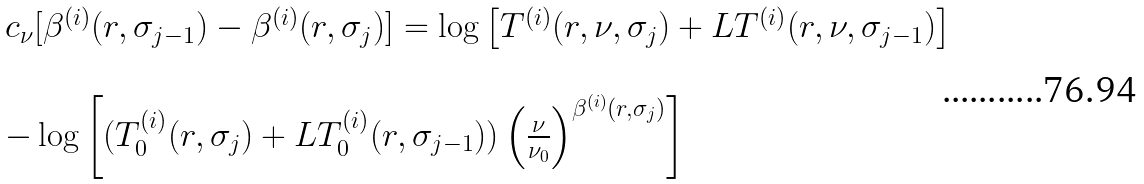<formula> <loc_0><loc_0><loc_500><loc_500>\begin{array} { l } c _ { \nu } [ \beta ^ { ( i ) } ( r , \sigma _ { j - 1 } ) - \beta ^ { ( i ) } ( r , \sigma _ { j } ) ] = \log \left [ T ^ { ( i ) } ( r , \nu , \sigma _ { j } ) + L T ^ { ( i ) } ( r , \nu , \sigma _ { j - 1 } ) \right ] \\ \\ - \log \left [ ( T ^ { ( i ) } _ { 0 } ( r , \sigma _ { j } ) + L T ^ { ( i ) } _ { 0 } ( r , \sigma _ { j - 1 } ) ) \left ( \frac { \nu } { \nu _ { 0 } } \right ) ^ { \beta ^ { ( i ) } ( r , \sigma _ { j } ) } \right ] \end{array}</formula> 